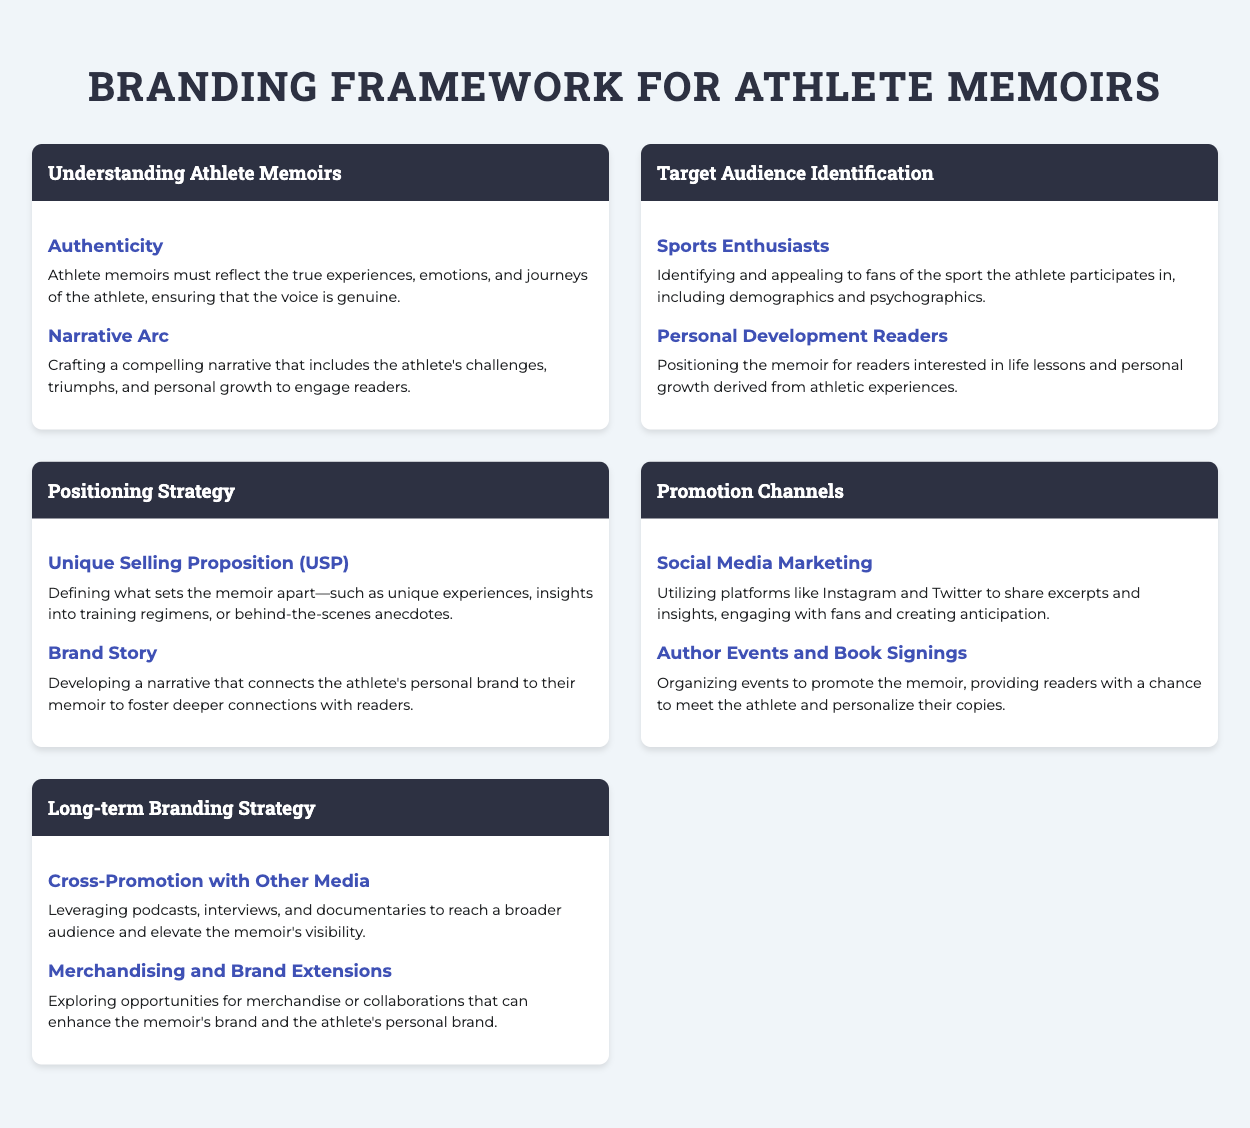what is the title of the document? The title of the document is presented at the top of the rendered page.
Answer: Branding Framework for Athlete Memoirs how many sections are in the document? The document comprises several sections that each contain key concepts.
Answer: 5 what is the first key concept under the section "Understanding Athlete Memoirs"? The first key concept listed in that section is the first mentioned under "key-concept".
Answer: Authenticity who is the target audience for athlete memoirs mentioned in the document? The target audiences identified include specific groups highlighted in the "Target Audience Identification" section.
Answer: Sports Enthusiasts which promotion channel involves utilizing social media platforms? This promotion channel is listed as a key concept under the "Promotion Channels" section.
Answer: Social Media Marketing what unique feature is mentioned in relation to the Positioning Strategy? The unique feature that differentiates the memoir is outlined in the section on Positioning Strategy.
Answer: Unique Selling Proposition (USP) which long-term branding strategy is suggested for reaching a broader audience? This strategy aims to leverage various media channels for increasing visibility and is part of the long-term strategy.
Answer: Cross-Promotion with Other Media what emotion should athlete memoirs reflect? This emotion is highlighted as a critical aspect of authenticity in memoir writing.
Answer: Genuine 